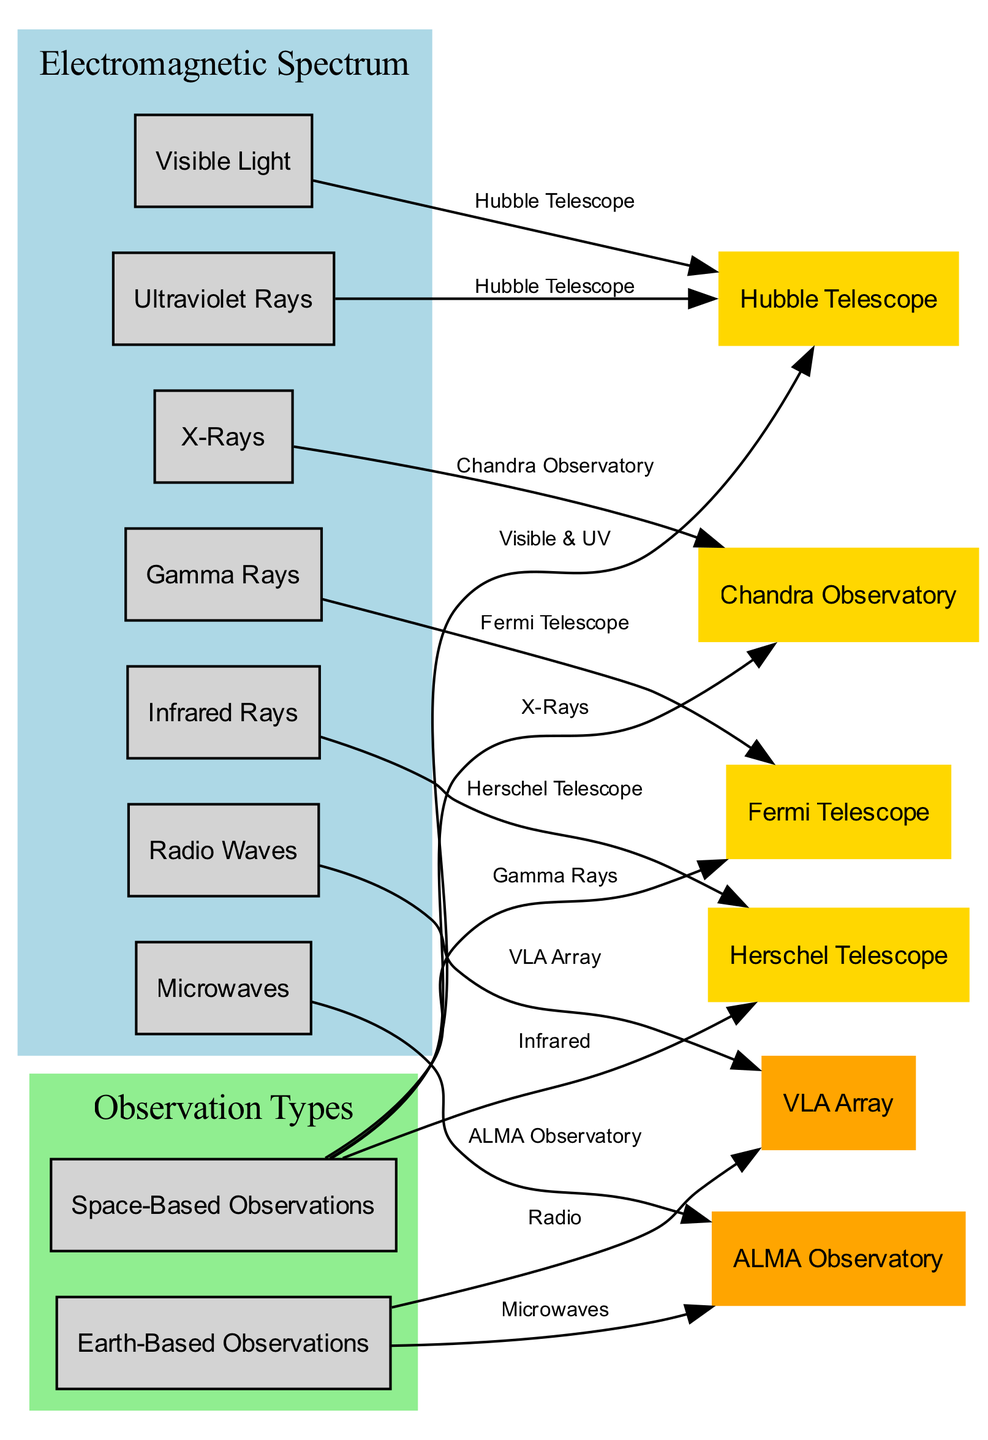What is the longest wavelength in the electromagnetic spectrum depicted in the diagram? The longest wavelength is represented by the node labeled "Radio Waves." This is at the beginning of the wavelengths section in the diagram.
Answer: Radio Waves Which telescope is associated with Ultraviolet Rays? The Hubble Telescope is connected to both Visible Light and Ultraviolet Rays. This can be seen in the edges from those wavelengths leading to the Hubble Telescope node.
Answer: Hubble Telescope How many space-based observation instruments are shown in the diagram? There are four space-based instruments: Herschel Telescope, Hubble Telescope, Chandra Observatory, and Fermi Telescope. By counting the nodes with the type 'space_based,' we get four instruments.
Answer: 4 What type of observations does the ALMA Observatory make? The ALMA Observatory is labeled for observing "Millimeter and submillimeter wavelengths." By looking at the node for ALMA Observatory, this specific observation type is described.
Answer: Microwaves Which type of rays is the Fermi Telescope used to observe? The Fermi Telescope is specifically labeled for observing "Gamma Rays," as indicated directly next to the node for the Fermi Telescope in the diagram.
Answer: Gamma Rays How many types of emitted wavelengths are connected to Earth-Based Observations? There are two wavelengths connected to Earth-Based Observations: Radio Waves and Microwaves. Counting the edges leading to the Earth-Based Observations node reveals these two types.
Answer: 2 Which observation type is attributed to the Herschel Telescope? The Herschel Telescope is attributed to "Infrared" observations, which is shown in the edge connecting it from the Infrared Rays node to the Herschel node.
Answer: Infrared What is the shortest wavelength in the electromagnetic spectrum depicted in the diagram? The shortest wavelength is represented by the node labeled "Gamma Rays," located at the end of the wavelength spectrum section within the diagram.
Answer: Gamma Rays Which observatory is used for X-ray observations? The Chandra Observatory is the one used for observations in the X-ray spectrum as labeled in its description and shown in the edge connecting to the X-rays node.
Answer: Chandra Observatory 